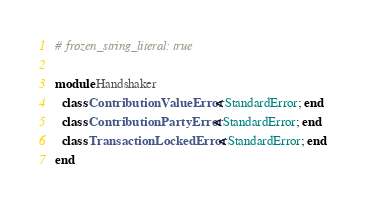<code> <loc_0><loc_0><loc_500><loc_500><_Ruby_># frozen_string_literal: true

module Handshaker
  class ContributionValueError < StandardError; end
  class ContributionPartyError < StandardError; end
  class TransactionLockedError < StandardError; end
end
</code> 